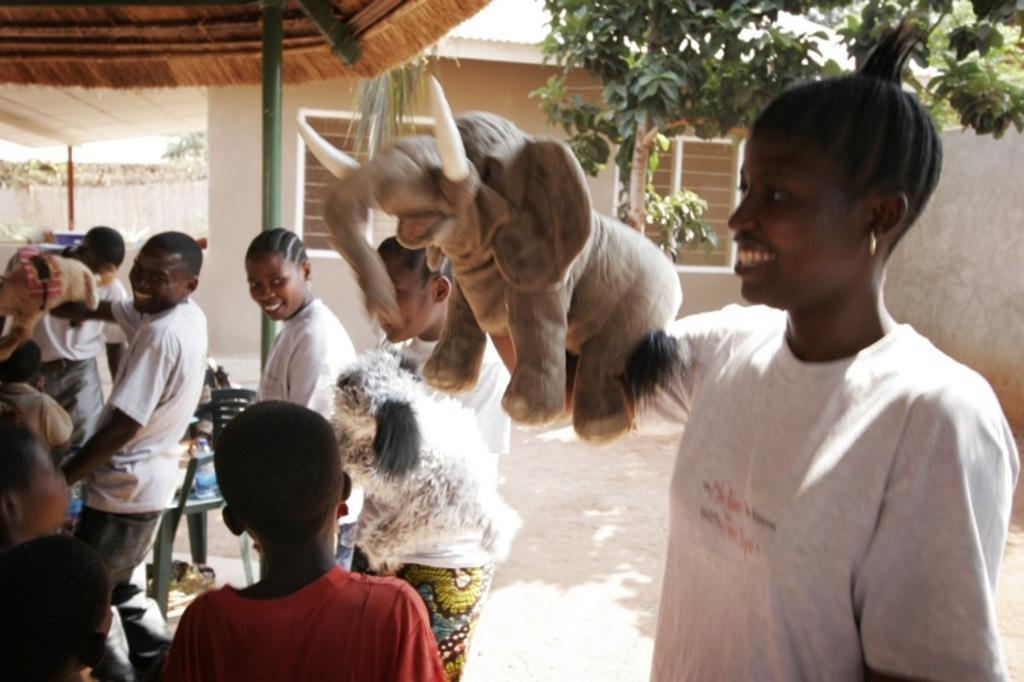How many people are in the group visible in the image? There is a group of people in the image, but the exact number cannot be determined from the provided facts. What type of objects can be seen in the image besides the people? There are toys and a chair visible in the image. What type of structure is present in the image? There is a shelter in the image. What can be seen in the background of the image? There are walls, trees, and a house with windows visible in the background of the image. What type of toothbrush is being used by the person in the image? There is no toothbrush present in the image. What type of rod is being used by the person in the image? There is no rod present in the image. 